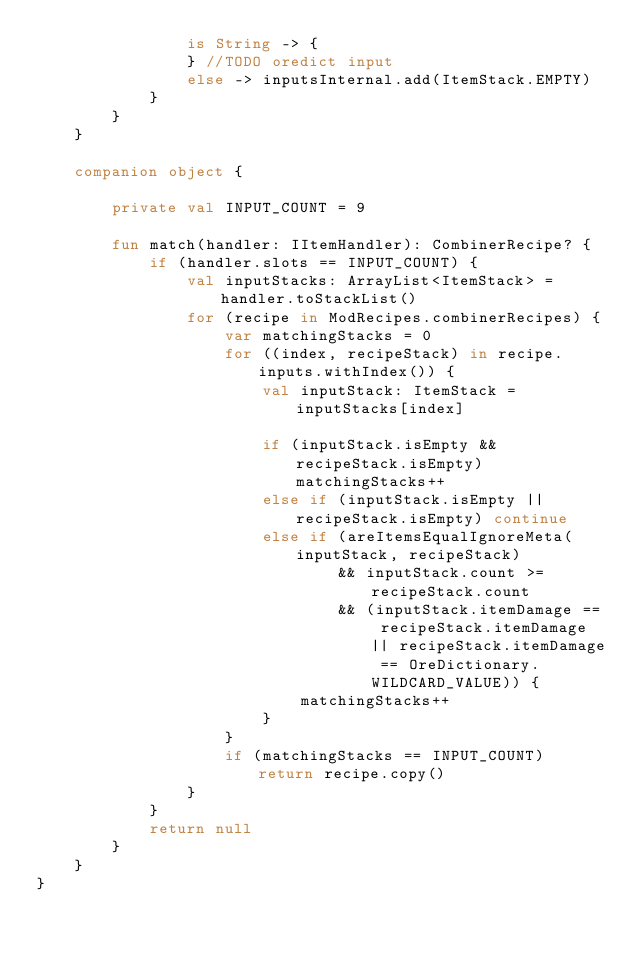Convert code to text. <code><loc_0><loc_0><loc_500><loc_500><_Kotlin_>                is String -> {
                } //TODO oredict input
                else -> inputsInternal.add(ItemStack.EMPTY)
            }
        }
    }

    companion object {

        private val INPUT_COUNT = 9

        fun match(handler: IItemHandler): CombinerRecipe? {
            if (handler.slots == INPUT_COUNT) {
                val inputStacks: ArrayList<ItemStack> = handler.toStackList()
                for (recipe in ModRecipes.combinerRecipes) {
                    var matchingStacks = 0
                    for ((index, recipeStack) in recipe.inputs.withIndex()) {
                        val inputStack: ItemStack = inputStacks[index]

                        if (inputStack.isEmpty && recipeStack.isEmpty) matchingStacks++
                        else if (inputStack.isEmpty || recipeStack.isEmpty) continue
                        else if (areItemsEqualIgnoreMeta(inputStack, recipeStack)
                                && inputStack.count >= recipeStack.count
                                && (inputStack.itemDamage == recipeStack.itemDamage || recipeStack.itemDamage == OreDictionary.WILDCARD_VALUE)) {
                            matchingStacks++
                        }
                    }
                    if (matchingStacks == INPUT_COUNT) return recipe.copy()
                }
            }
            return null
        }
    }
}</code> 